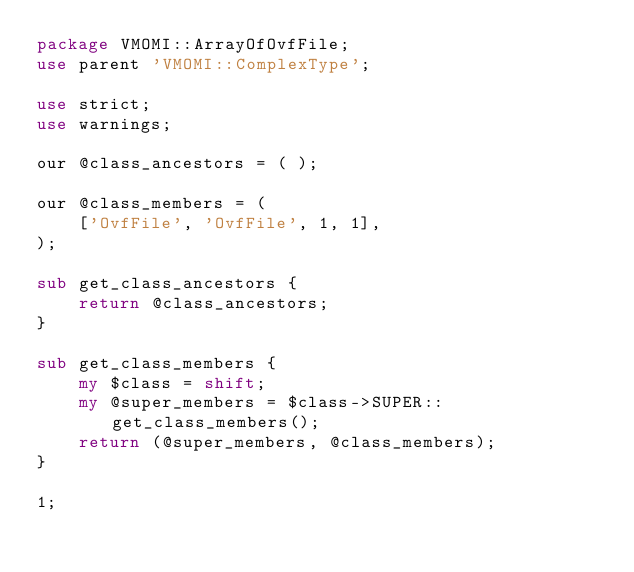Convert code to text. <code><loc_0><loc_0><loc_500><loc_500><_Perl_>package VMOMI::ArrayOfOvfFile;
use parent 'VMOMI::ComplexType';

use strict;
use warnings;

our @class_ancestors = ( );

our @class_members = ( 
    ['OvfFile', 'OvfFile', 1, 1],
);

sub get_class_ancestors {
    return @class_ancestors;
}

sub get_class_members {
    my $class = shift;
    my @super_members = $class->SUPER::get_class_members();
    return (@super_members, @class_members);
}

1;
</code> 